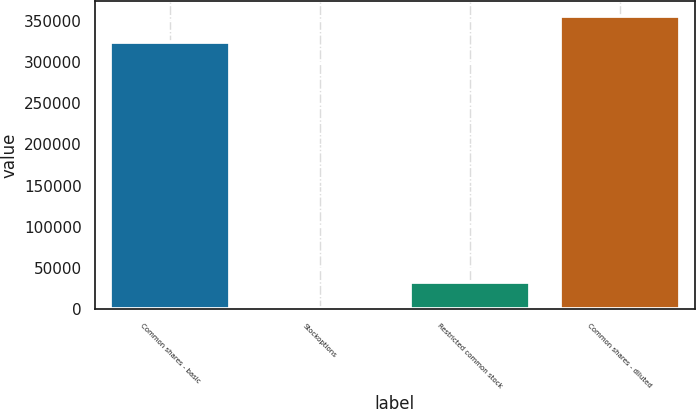<chart> <loc_0><loc_0><loc_500><loc_500><bar_chart><fcel>Common shares - basic<fcel>Stockoptions<fcel>Restricted common stock<fcel>Common shares - diluted<nl><fcel>323890<fcel>836<fcel>33348.9<fcel>356403<nl></chart> 